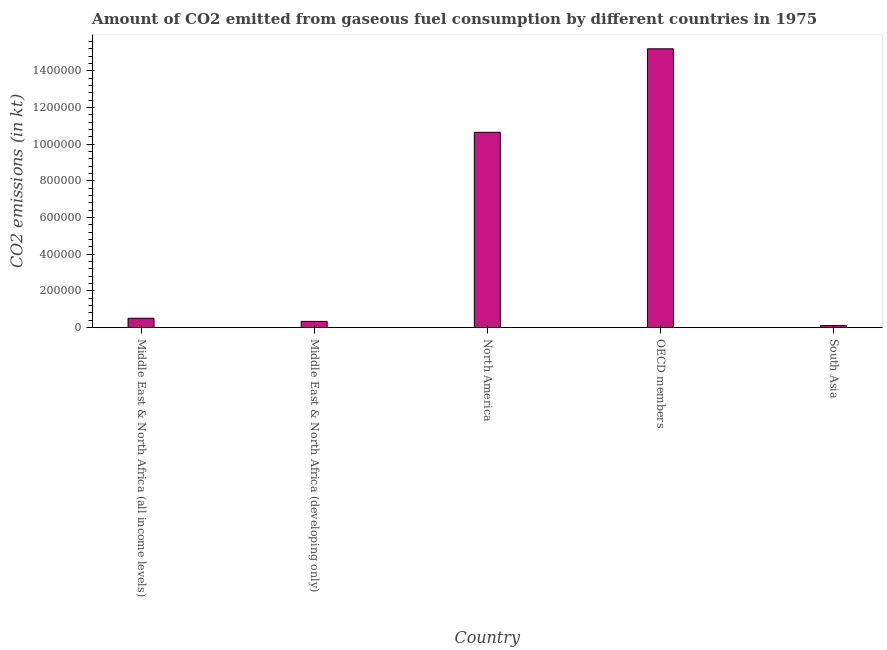Does the graph contain any zero values?
Keep it short and to the point. No. Does the graph contain grids?
Your answer should be compact. No. What is the title of the graph?
Offer a terse response. Amount of CO2 emitted from gaseous fuel consumption by different countries in 1975. What is the label or title of the X-axis?
Your response must be concise. Country. What is the label or title of the Y-axis?
Make the answer very short. CO2 emissions (in kt). What is the co2 emissions from gaseous fuel consumption in North America?
Your answer should be very brief. 1.07e+06. Across all countries, what is the maximum co2 emissions from gaseous fuel consumption?
Provide a short and direct response. 1.52e+06. Across all countries, what is the minimum co2 emissions from gaseous fuel consumption?
Offer a terse response. 1.11e+04. In which country was the co2 emissions from gaseous fuel consumption maximum?
Offer a terse response. OECD members. What is the sum of the co2 emissions from gaseous fuel consumption?
Provide a succinct answer. 2.68e+06. What is the difference between the co2 emissions from gaseous fuel consumption in Middle East & North Africa (all income levels) and OECD members?
Your response must be concise. -1.47e+06. What is the average co2 emissions from gaseous fuel consumption per country?
Make the answer very short. 5.37e+05. What is the median co2 emissions from gaseous fuel consumption?
Give a very brief answer. 5.13e+04. What is the ratio of the co2 emissions from gaseous fuel consumption in Middle East & North Africa (developing only) to that in OECD members?
Keep it short and to the point. 0.02. Is the difference between the co2 emissions from gaseous fuel consumption in Middle East & North Africa (all income levels) and South Asia greater than the difference between any two countries?
Offer a very short reply. No. What is the difference between the highest and the second highest co2 emissions from gaseous fuel consumption?
Keep it short and to the point. 4.55e+05. What is the difference between the highest and the lowest co2 emissions from gaseous fuel consumption?
Provide a succinct answer. 1.51e+06. In how many countries, is the co2 emissions from gaseous fuel consumption greater than the average co2 emissions from gaseous fuel consumption taken over all countries?
Provide a short and direct response. 2. Are all the bars in the graph horizontal?
Provide a succinct answer. No. How many countries are there in the graph?
Your answer should be compact. 5. What is the difference between two consecutive major ticks on the Y-axis?
Provide a succinct answer. 2.00e+05. Are the values on the major ticks of Y-axis written in scientific E-notation?
Provide a short and direct response. No. What is the CO2 emissions (in kt) of Middle East & North Africa (all income levels)?
Your response must be concise. 5.13e+04. What is the CO2 emissions (in kt) in Middle East & North Africa (developing only)?
Ensure brevity in your answer.  3.42e+04. What is the CO2 emissions (in kt) of North America?
Offer a terse response. 1.07e+06. What is the CO2 emissions (in kt) in OECD members?
Your answer should be very brief. 1.52e+06. What is the CO2 emissions (in kt) in South Asia?
Give a very brief answer. 1.11e+04. What is the difference between the CO2 emissions (in kt) in Middle East & North Africa (all income levels) and Middle East & North Africa (developing only)?
Your response must be concise. 1.70e+04. What is the difference between the CO2 emissions (in kt) in Middle East & North Africa (all income levels) and North America?
Your response must be concise. -1.01e+06. What is the difference between the CO2 emissions (in kt) in Middle East & North Africa (all income levels) and OECD members?
Your answer should be very brief. -1.47e+06. What is the difference between the CO2 emissions (in kt) in Middle East & North Africa (all income levels) and South Asia?
Your answer should be compact. 4.01e+04. What is the difference between the CO2 emissions (in kt) in Middle East & North Africa (developing only) and North America?
Offer a very short reply. -1.03e+06. What is the difference between the CO2 emissions (in kt) in Middle East & North Africa (developing only) and OECD members?
Keep it short and to the point. -1.49e+06. What is the difference between the CO2 emissions (in kt) in Middle East & North Africa (developing only) and South Asia?
Provide a succinct answer. 2.31e+04. What is the difference between the CO2 emissions (in kt) in North America and OECD members?
Ensure brevity in your answer.  -4.55e+05. What is the difference between the CO2 emissions (in kt) in North America and South Asia?
Your answer should be compact. 1.05e+06. What is the difference between the CO2 emissions (in kt) in OECD members and South Asia?
Ensure brevity in your answer.  1.51e+06. What is the ratio of the CO2 emissions (in kt) in Middle East & North Africa (all income levels) to that in Middle East & North Africa (developing only)?
Offer a very short reply. 1.5. What is the ratio of the CO2 emissions (in kt) in Middle East & North Africa (all income levels) to that in North America?
Your response must be concise. 0.05. What is the ratio of the CO2 emissions (in kt) in Middle East & North Africa (all income levels) to that in OECD members?
Keep it short and to the point. 0.03. What is the ratio of the CO2 emissions (in kt) in Middle East & North Africa (all income levels) to that in South Asia?
Keep it short and to the point. 4.6. What is the ratio of the CO2 emissions (in kt) in Middle East & North Africa (developing only) to that in North America?
Provide a short and direct response. 0.03. What is the ratio of the CO2 emissions (in kt) in Middle East & North Africa (developing only) to that in OECD members?
Provide a succinct answer. 0.02. What is the ratio of the CO2 emissions (in kt) in Middle East & North Africa (developing only) to that in South Asia?
Provide a short and direct response. 3.07. What is the ratio of the CO2 emissions (in kt) in North America to that in OECD members?
Provide a succinct answer. 0.7. What is the ratio of the CO2 emissions (in kt) in North America to that in South Asia?
Give a very brief answer. 95.66. What is the ratio of the CO2 emissions (in kt) in OECD members to that in South Asia?
Your response must be concise. 136.55. 